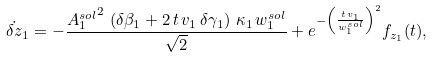<formula> <loc_0><loc_0><loc_500><loc_500>\dot { \delta z } _ { 1 } = - \frac { { A _ { 1 } ^ { s o l } } ^ { 2 } \, \left ( \delta \beta _ { 1 } + 2 \, t \, { v _ { 1 } } \, \delta \gamma _ { 1 } \right ) \, { { \kappa } _ { 1 } } \, w _ { 1 } ^ { s o l } } { { \sqrt { 2 } } } + e ^ { - \left ( \frac { t \, v _ { 1 } } { w _ { 1 } ^ { s o l } } \right ) ^ { 2 } } f _ { z _ { 1 } } ( t ) ,</formula> 